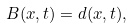Convert formula to latex. <formula><loc_0><loc_0><loc_500><loc_500>B ( x , t ) = d ( x , t ) ,</formula> 